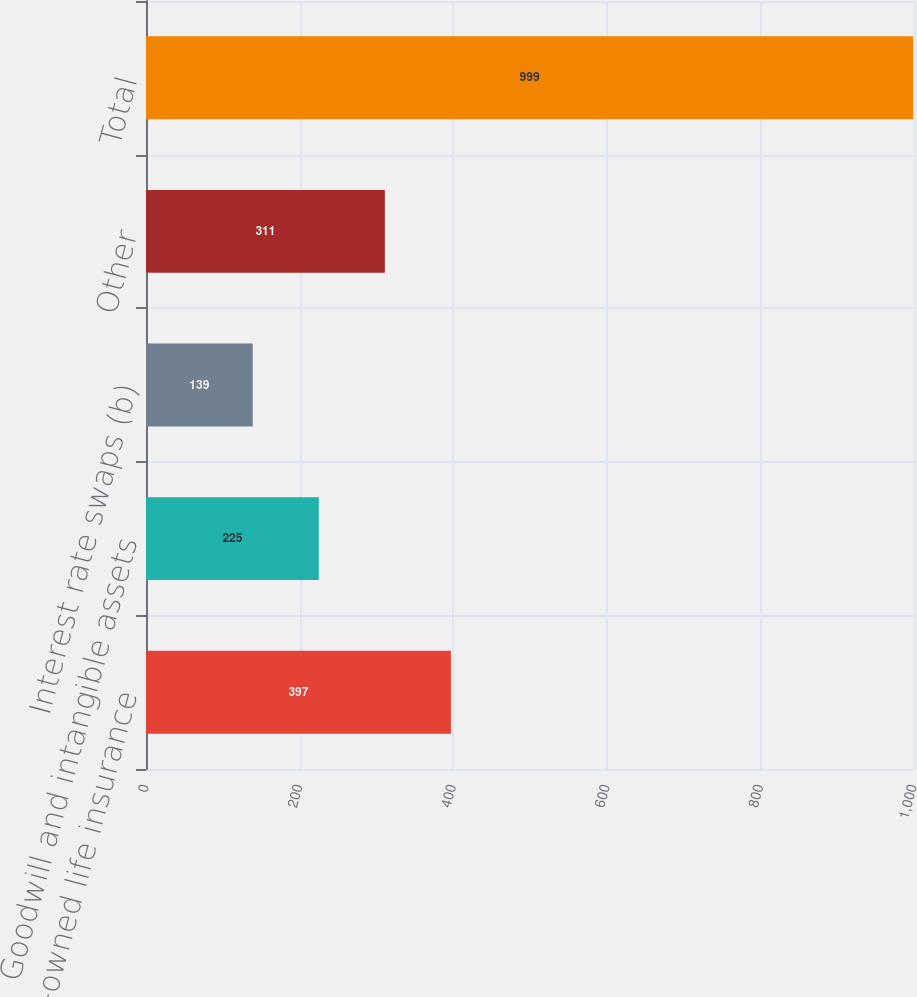<chart> <loc_0><loc_0><loc_500><loc_500><bar_chart><fcel>Company-owned life insurance<fcel>Goodwill and intangible assets<fcel>Interest rate swaps (b)<fcel>Other<fcel>Total<nl><fcel>397<fcel>225<fcel>139<fcel>311<fcel>999<nl></chart> 